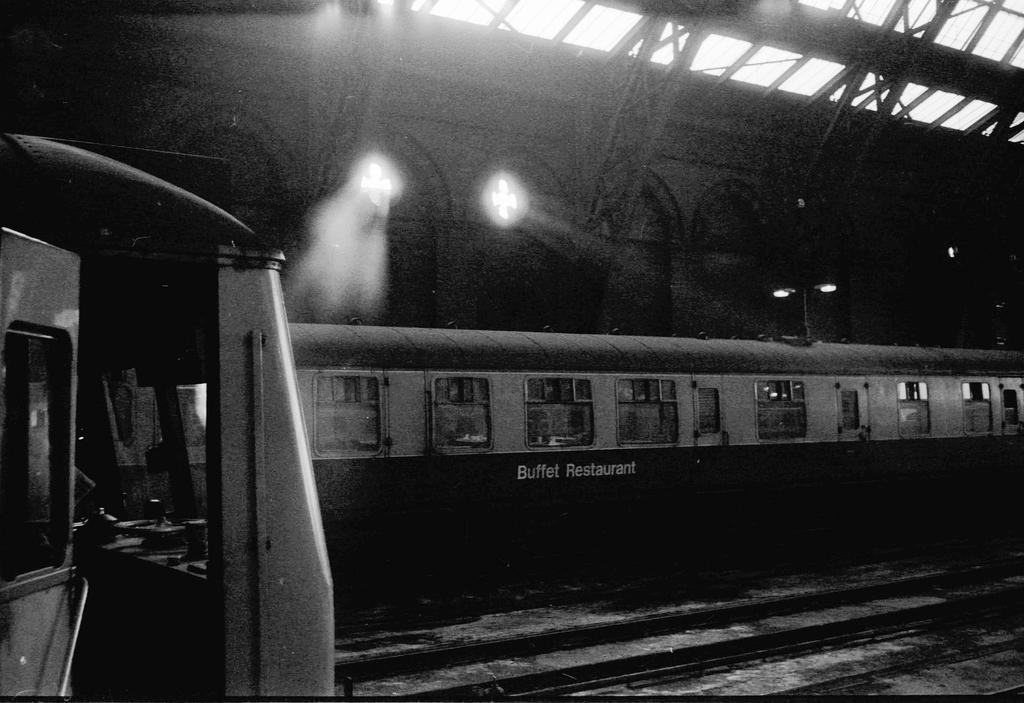Describe this image in one or two sentences. This picture might be taken in a railway station, in this picture in the center there is one train. And in the background there are some towers, wall and some iron rods. On the left side there is one vehicle, at the bottom there is a railway track. 